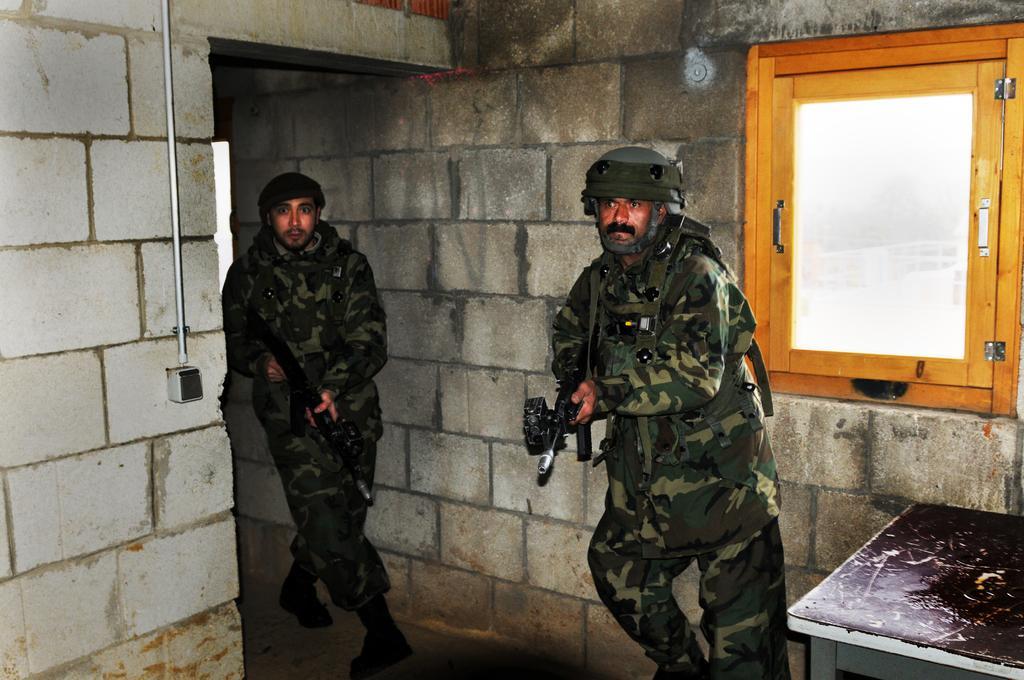Please provide a concise description of this image. In this image I can see inside view of a building and in the centre I can see two men are standing. I can see both of them are wearing uniforms, helmets and both of them are holding guns. On the right side of this image I can see a window and a table. On the left side of this image I can see a switch board on the wall. 